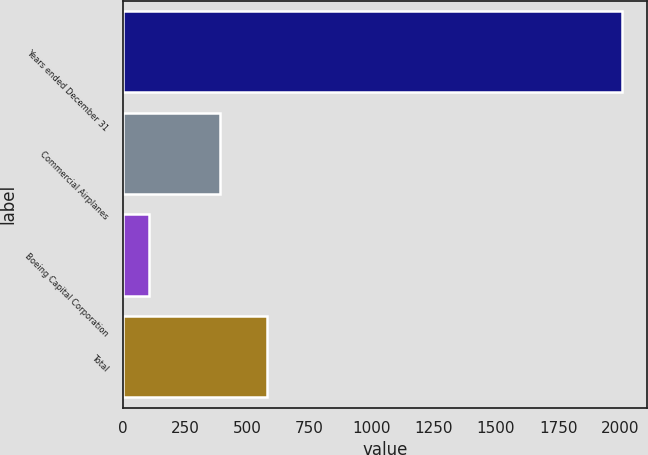<chart> <loc_0><loc_0><loc_500><loc_500><bar_chart><fcel>Years ended December 31<fcel>Commercial Airplanes<fcel>Boeing Capital Corporation<fcel>Total<nl><fcel>2007<fcel>390<fcel>103<fcel>580.4<nl></chart> 